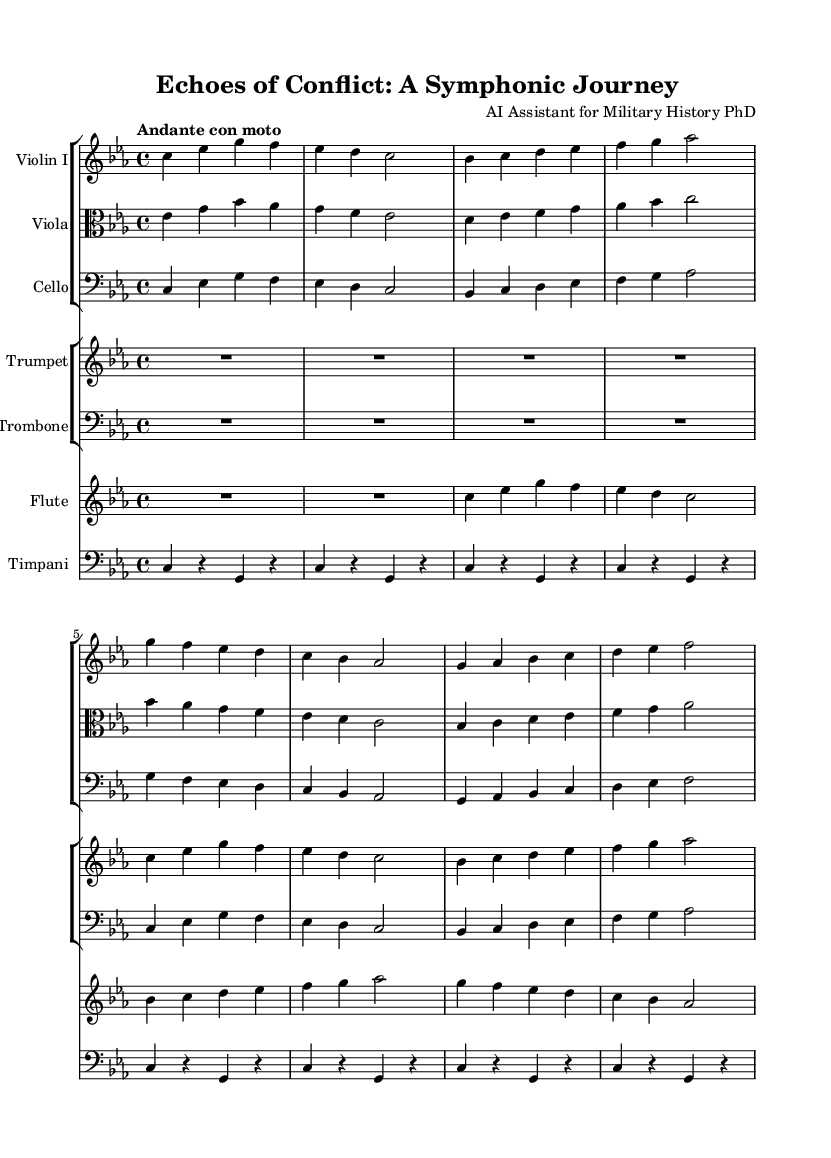What is the key signature of this music? The key signature shown at the beginning of the score is C minor, which has three flats: B flat, E flat, and A flat.
Answer: C minor What is the time signature of this piece? The time signature indicated in the music sheet is 4/4, which means there are four beats per measure and a quarter note receives one beat.
Answer: 4/4 What is the tempo marking for the symphony? The tempo marking specified at the beginning is "Andante con moto," which indicates a moderately slow pace with a slight movement.
Answer: Andante con moto How many distinct instruments are used in this symphony? There are six distinct instruments shown in the score: Violin I, Viola, Cello, Trumpet, Trombone, Flute, and Timpani.
Answer: Six What is the rhythmic pattern primarily used in the timpani part? The timpani part predominantly consists of a repeating pattern featuring long rests followed by quarter notes, primarily alternating around the pitch C and G.
Answer: Repeating pattern with long rests Which instruments are utilizing electronic sounds in the symphony? This score does not specifically indicate electronic sounds in the presented sheet music; however, they typically accompany traditional instruments throughout the performance.
Answer: Not specified In which section does the theme transition from medieval to modern warfare? The transition is represented by variations in dynamics and texture, especially in the interaction between strings and brass instruments before the flute introduces contemporary elements later in the piece.
Answer: Dynamic variations 